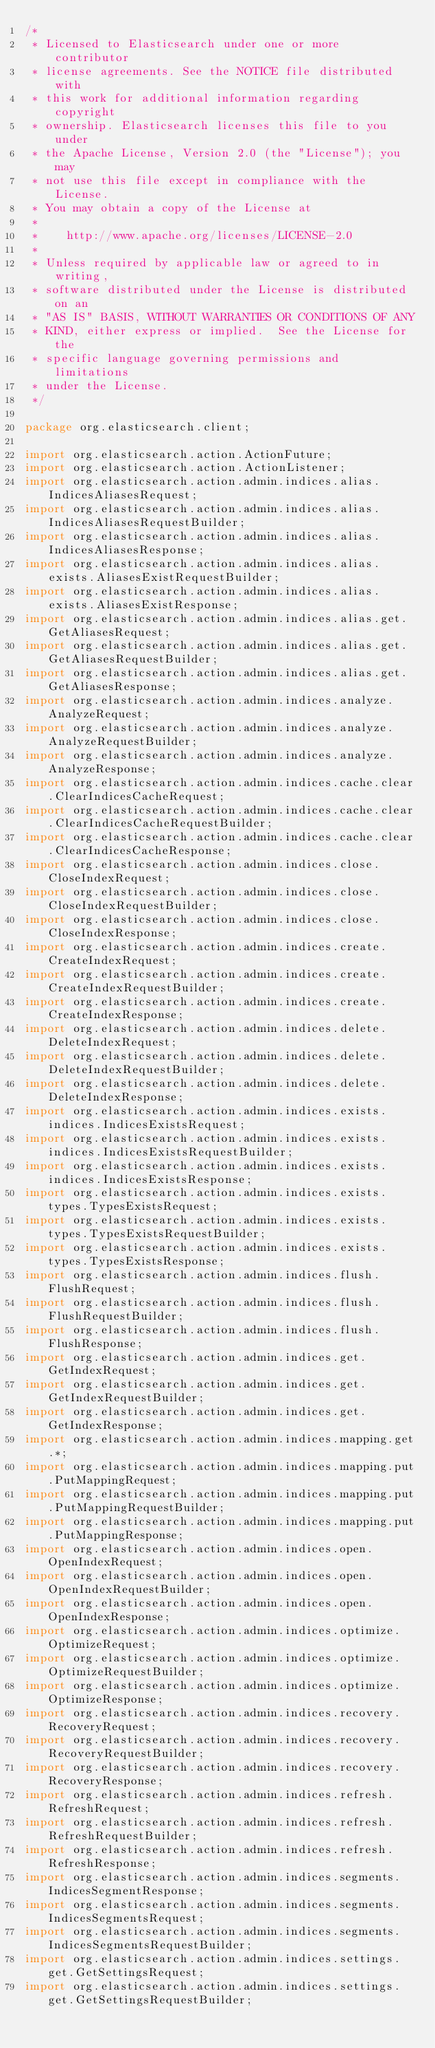Convert code to text. <code><loc_0><loc_0><loc_500><loc_500><_Java_>/*
 * Licensed to Elasticsearch under one or more contributor
 * license agreements. See the NOTICE file distributed with
 * this work for additional information regarding copyright
 * ownership. Elasticsearch licenses this file to you under
 * the Apache License, Version 2.0 (the "License"); you may
 * not use this file except in compliance with the License.
 * You may obtain a copy of the License at
 *
 *    http://www.apache.org/licenses/LICENSE-2.0
 *
 * Unless required by applicable law or agreed to in writing,
 * software distributed under the License is distributed on an
 * "AS IS" BASIS, WITHOUT WARRANTIES OR CONDITIONS OF ANY
 * KIND, either express or implied.  See the License for the
 * specific language governing permissions and limitations
 * under the License.
 */

package org.elasticsearch.client;

import org.elasticsearch.action.ActionFuture;
import org.elasticsearch.action.ActionListener;
import org.elasticsearch.action.admin.indices.alias.IndicesAliasesRequest;
import org.elasticsearch.action.admin.indices.alias.IndicesAliasesRequestBuilder;
import org.elasticsearch.action.admin.indices.alias.IndicesAliasesResponse;
import org.elasticsearch.action.admin.indices.alias.exists.AliasesExistRequestBuilder;
import org.elasticsearch.action.admin.indices.alias.exists.AliasesExistResponse;
import org.elasticsearch.action.admin.indices.alias.get.GetAliasesRequest;
import org.elasticsearch.action.admin.indices.alias.get.GetAliasesRequestBuilder;
import org.elasticsearch.action.admin.indices.alias.get.GetAliasesResponse;
import org.elasticsearch.action.admin.indices.analyze.AnalyzeRequest;
import org.elasticsearch.action.admin.indices.analyze.AnalyzeRequestBuilder;
import org.elasticsearch.action.admin.indices.analyze.AnalyzeResponse;
import org.elasticsearch.action.admin.indices.cache.clear.ClearIndicesCacheRequest;
import org.elasticsearch.action.admin.indices.cache.clear.ClearIndicesCacheRequestBuilder;
import org.elasticsearch.action.admin.indices.cache.clear.ClearIndicesCacheResponse;
import org.elasticsearch.action.admin.indices.close.CloseIndexRequest;
import org.elasticsearch.action.admin.indices.close.CloseIndexRequestBuilder;
import org.elasticsearch.action.admin.indices.close.CloseIndexResponse;
import org.elasticsearch.action.admin.indices.create.CreateIndexRequest;
import org.elasticsearch.action.admin.indices.create.CreateIndexRequestBuilder;
import org.elasticsearch.action.admin.indices.create.CreateIndexResponse;
import org.elasticsearch.action.admin.indices.delete.DeleteIndexRequest;
import org.elasticsearch.action.admin.indices.delete.DeleteIndexRequestBuilder;
import org.elasticsearch.action.admin.indices.delete.DeleteIndexResponse;
import org.elasticsearch.action.admin.indices.exists.indices.IndicesExistsRequest;
import org.elasticsearch.action.admin.indices.exists.indices.IndicesExistsRequestBuilder;
import org.elasticsearch.action.admin.indices.exists.indices.IndicesExistsResponse;
import org.elasticsearch.action.admin.indices.exists.types.TypesExistsRequest;
import org.elasticsearch.action.admin.indices.exists.types.TypesExistsRequestBuilder;
import org.elasticsearch.action.admin.indices.exists.types.TypesExistsResponse;
import org.elasticsearch.action.admin.indices.flush.FlushRequest;
import org.elasticsearch.action.admin.indices.flush.FlushRequestBuilder;
import org.elasticsearch.action.admin.indices.flush.FlushResponse;
import org.elasticsearch.action.admin.indices.get.GetIndexRequest;
import org.elasticsearch.action.admin.indices.get.GetIndexRequestBuilder;
import org.elasticsearch.action.admin.indices.get.GetIndexResponse;
import org.elasticsearch.action.admin.indices.mapping.get.*;
import org.elasticsearch.action.admin.indices.mapping.put.PutMappingRequest;
import org.elasticsearch.action.admin.indices.mapping.put.PutMappingRequestBuilder;
import org.elasticsearch.action.admin.indices.mapping.put.PutMappingResponse;
import org.elasticsearch.action.admin.indices.open.OpenIndexRequest;
import org.elasticsearch.action.admin.indices.open.OpenIndexRequestBuilder;
import org.elasticsearch.action.admin.indices.open.OpenIndexResponse;
import org.elasticsearch.action.admin.indices.optimize.OptimizeRequest;
import org.elasticsearch.action.admin.indices.optimize.OptimizeRequestBuilder;
import org.elasticsearch.action.admin.indices.optimize.OptimizeResponse;
import org.elasticsearch.action.admin.indices.recovery.RecoveryRequest;
import org.elasticsearch.action.admin.indices.recovery.RecoveryRequestBuilder;
import org.elasticsearch.action.admin.indices.recovery.RecoveryResponse;
import org.elasticsearch.action.admin.indices.refresh.RefreshRequest;
import org.elasticsearch.action.admin.indices.refresh.RefreshRequestBuilder;
import org.elasticsearch.action.admin.indices.refresh.RefreshResponse;
import org.elasticsearch.action.admin.indices.segments.IndicesSegmentResponse;
import org.elasticsearch.action.admin.indices.segments.IndicesSegmentsRequest;
import org.elasticsearch.action.admin.indices.segments.IndicesSegmentsRequestBuilder;
import org.elasticsearch.action.admin.indices.settings.get.GetSettingsRequest;
import org.elasticsearch.action.admin.indices.settings.get.GetSettingsRequestBuilder;</code> 